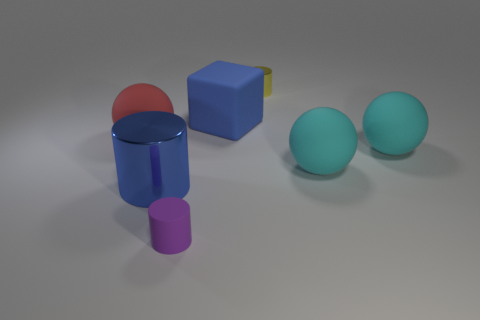Subtract all large cyan matte balls. How many balls are left? 1 Add 1 big blue matte blocks. How many objects exist? 8 Subtract all cylinders. How many objects are left? 4 Add 5 purple blocks. How many purple blocks exist? 5 Subtract 0 green balls. How many objects are left? 7 Subtract all big cyan rubber balls. Subtract all big blocks. How many objects are left? 4 Add 4 red rubber objects. How many red rubber objects are left? 5 